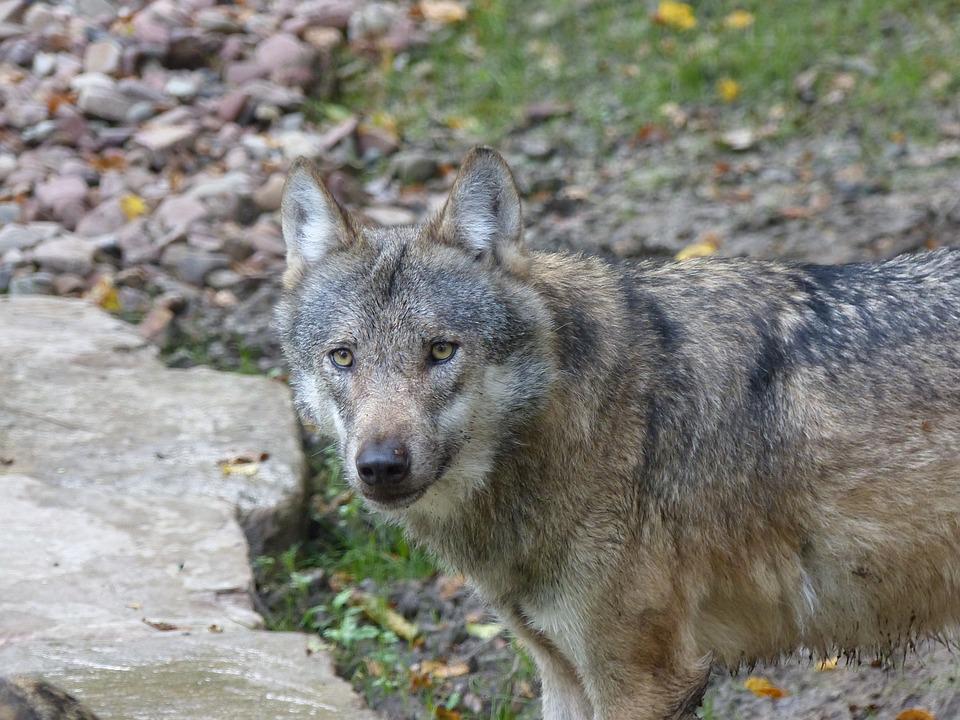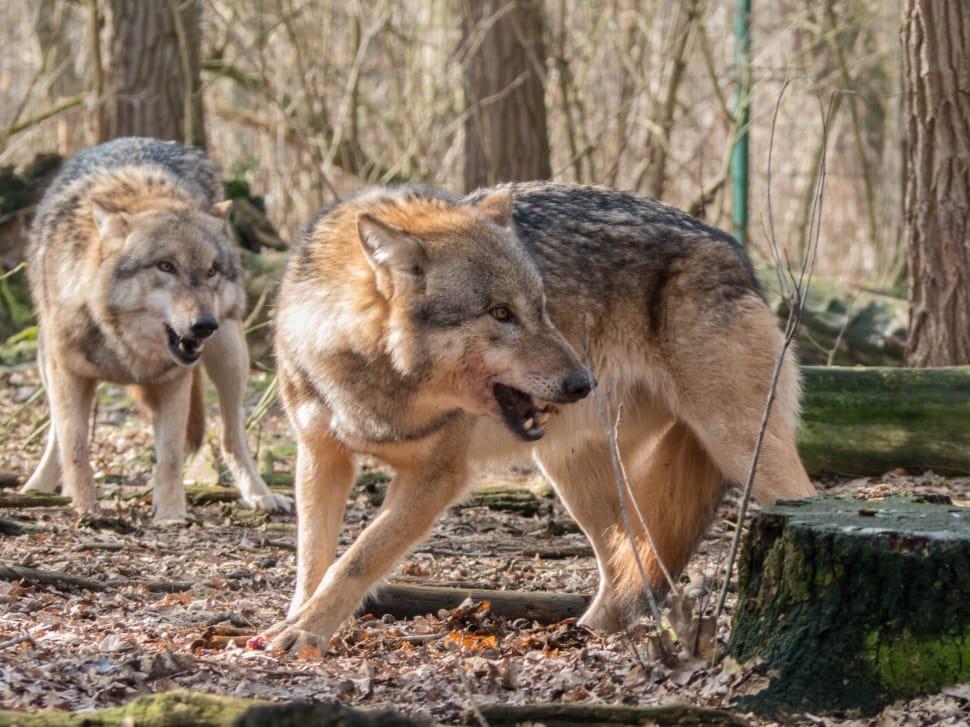The first image is the image on the left, the second image is the image on the right. Considering the images on both sides, is "One image includes exactly twice as many wolves as the other image." valid? Answer yes or no. Yes. The first image is the image on the left, the second image is the image on the right. Assess this claim about the two images: "There are three wolves". Correct or not? Answer yes or no. Yes. 